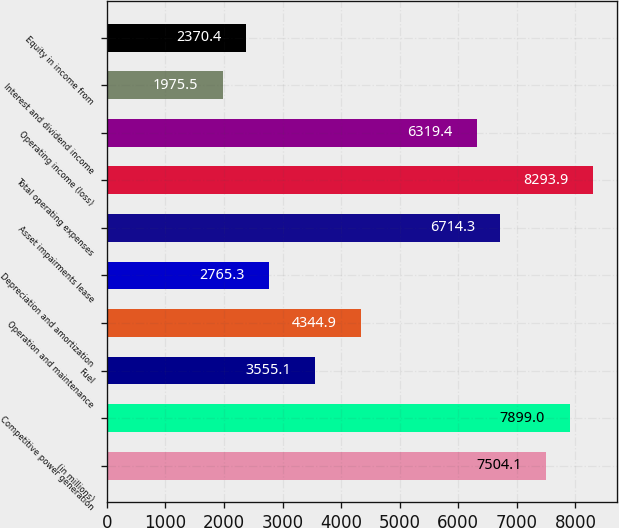Convert chart. <chart><loc_0><loc_0><loc_500><loc_500><bar_chart><fcel>(in millions)<fcel>Competitive power generation<fcel>Fuel<fcel>Operation and maintenance<fcel>Depreciation and amortization<fcel>Asset impairments lease<fcel>Total operating expenses<fcel>Operating income (loss)<fcel>Interest and dividend income<fcel>Equity in income from<nl><fcel>7504.1<fcel>7899<fcel>3555.1<fcel>4344.9<fcel>2765.3<fcel>6714.3<fcel>8293.9<fcel>6319.4<fcel>1975.5<fcel>2370.4<nl></chart> 